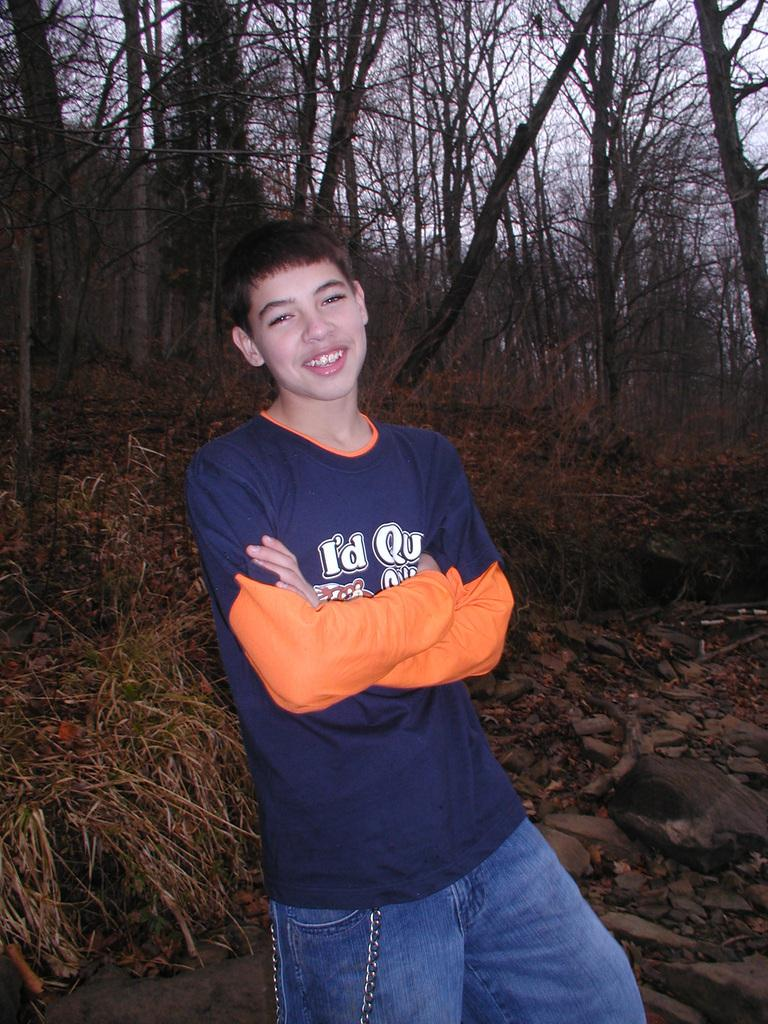<image>
Provide a brief description of the given image. A boy is wearing a blue tee that says "i'd qu..." but the rest of the text is obscured by his arm. 